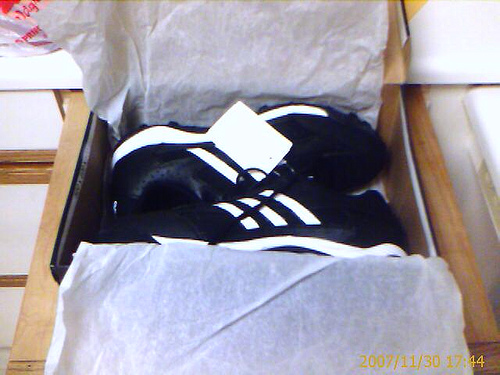<image>
Is there a shoe in the box? Yes. The shoe is contained within or inside the box, showing a containment relationship. 